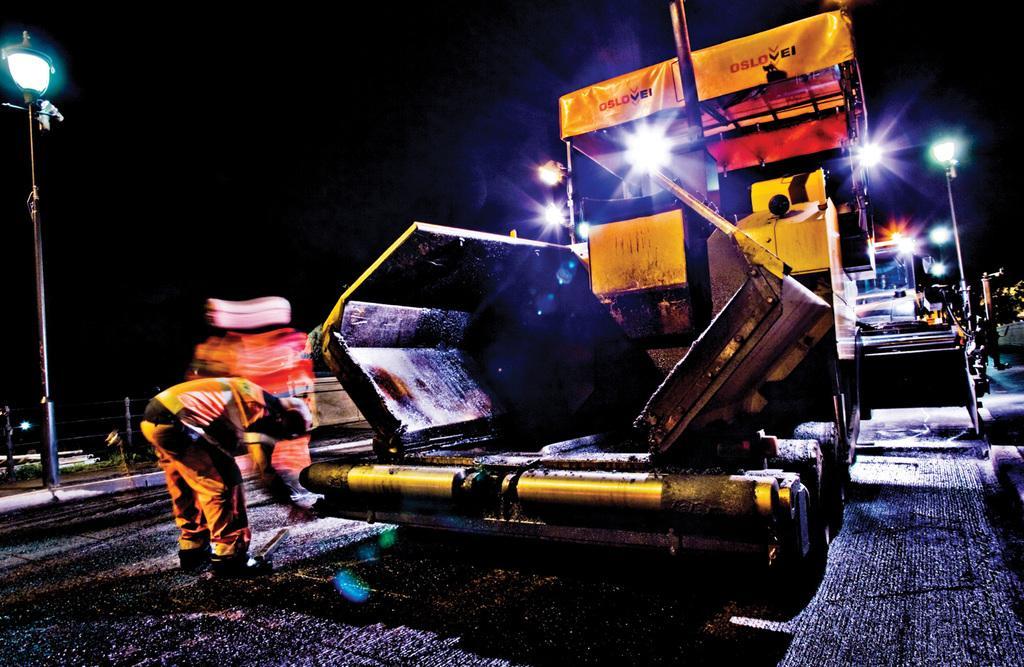In one or two sentences, can you explain what this image depicts? In this image we can see a person standing beside a vehicle which is placed on the ground. We can also see the street lamps, a fence and some lights. On the right side we can see a person standing. 